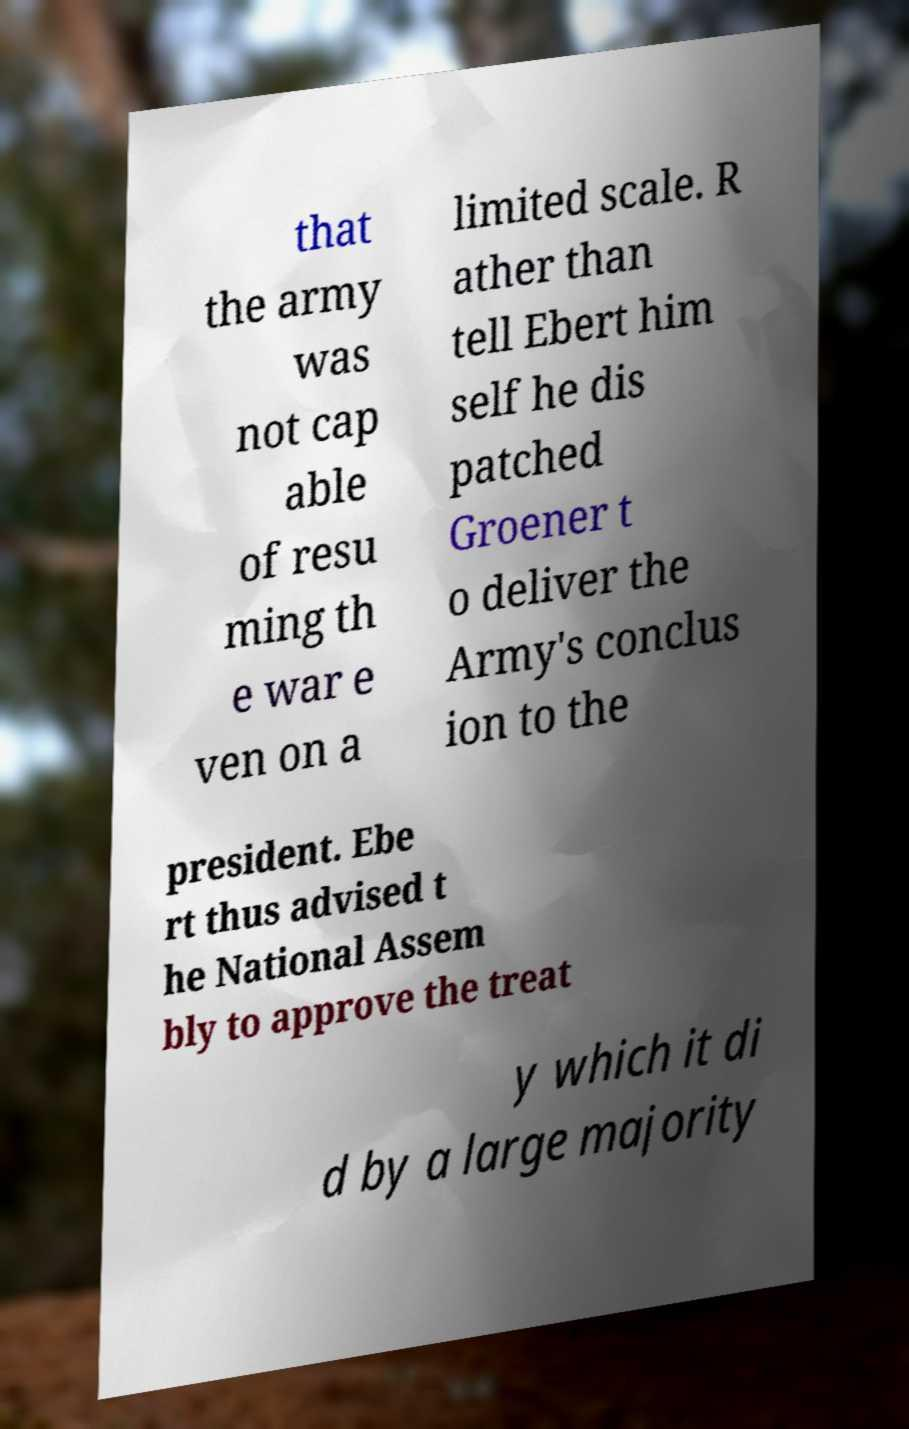Please read and relay the text visible in this image. What does it say? that the army was not cap able of resu ming th e war e ven on a limited scale. R ather than tell Ebert him self he dis patched Groener t o deliver the Army's conclus ion to the president. Ebe rt thus advised t he National Assem bly to approve the treat y which it di d by a large majority 